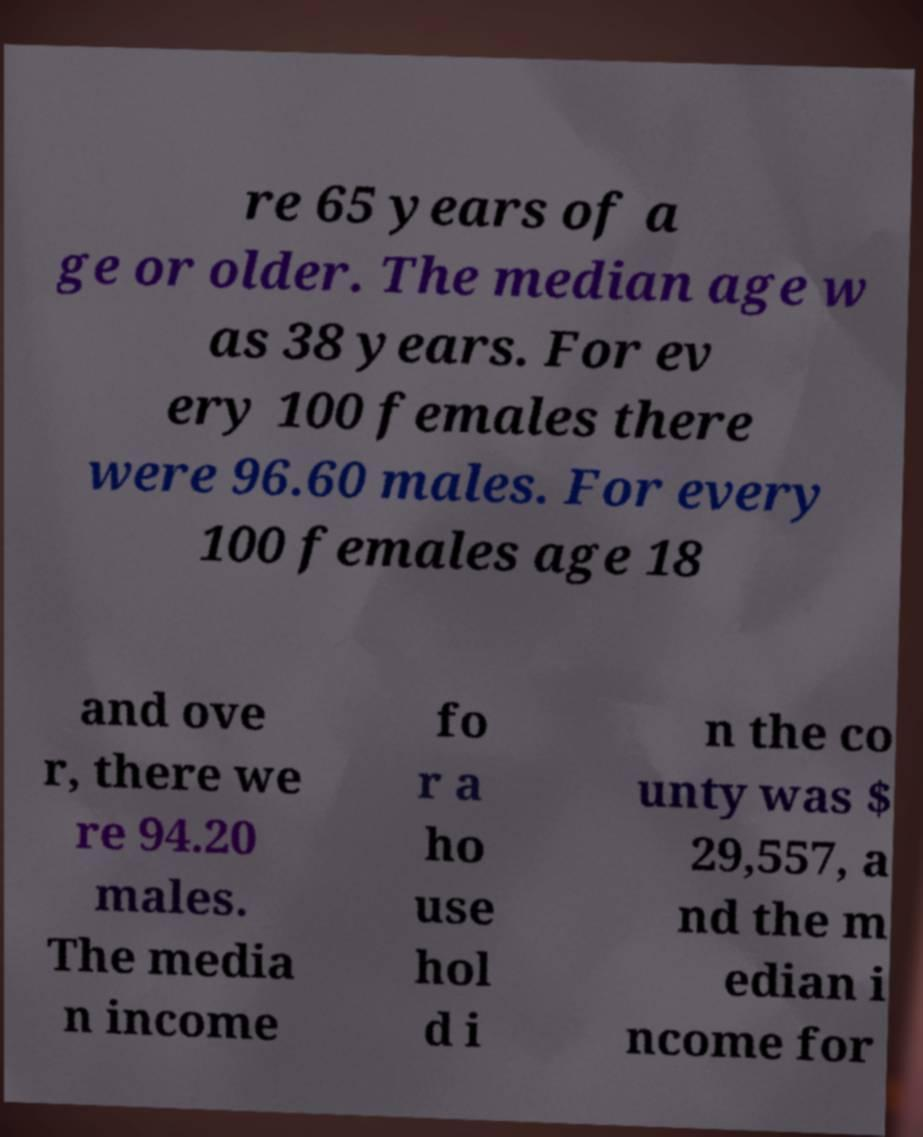There's text embedded in this image that I need extracted. Can you transcribe it verbatim? re 65 years of a ge or older. The median age w as 38 years. For ev ery 100 females there were 96.60 males. For every 100 females age 18 and ove r, there we re 94.20 males. The media n income fo r a ho use hol d i n the co unty was $ 29,557, a nd the m edian i ncome for 